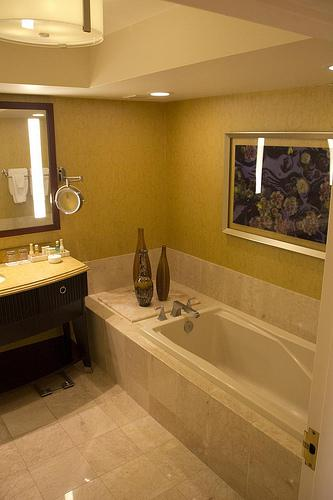Question: where was this taken?
Choices:
A. The bathroom.
B. The kitchen.
C. The den.
D. The laundry room.
Answer with the letter. Answer: A Question: how many bathtubs?
Choices:
A. 2.
B. 4.
C. 1.
D. 6.
Answer with the letter. Answer: C Question: what room is this?
Choices:
A. Kitchen.
B. Bathroom.
C. Bedroom.
D. Living room.
Answer with the letter. Answer: B Question: what color is the wall?
Choices:
A. Orange.
B. Yellow.
C. White.
D. Blue.
Answer with the letter. Answer: B Question: why is the light on?
Choices:
A. It is dark.
B. To read.
C. Too see.
D. To write.
Answer with the letter. Answer: C 